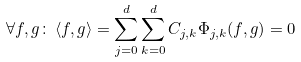Convert formula to latex. <formula><loc_0><loc_0><loc_500><loc_500>\forall f , g \colon \, \langle f , g \rangle = \sum _ { j = 0 } ^ { d } \sum _ { k = 0 } ^ { d } C _ { j , k } \Phi _ { j , k } ( f , g ) = 0</formula> 